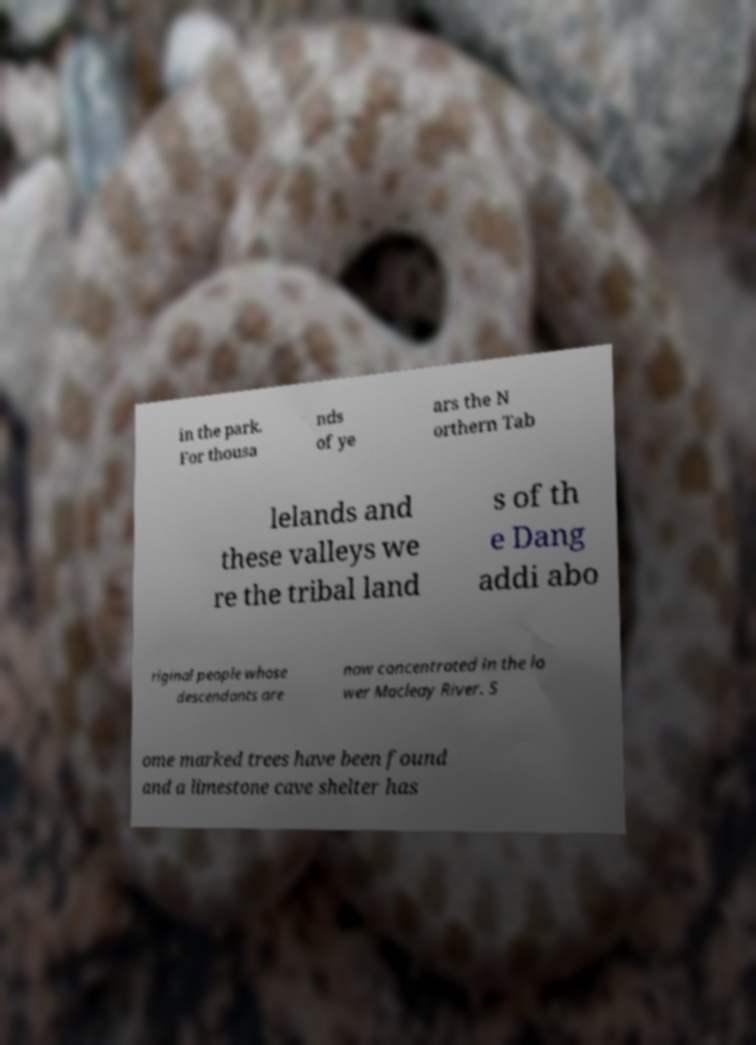For documentation purposes, I need the text within this image transcribed. Could you provide that? in the park. For thousa nds of ye ars the N orthern Tab lelands and these valleys we re the tribal land s of th e Dang addi abo riginal people whose descendants are now concentrated in the lo wer Macleay River. S ome marked trees have been found and a limestone cave shelter has 